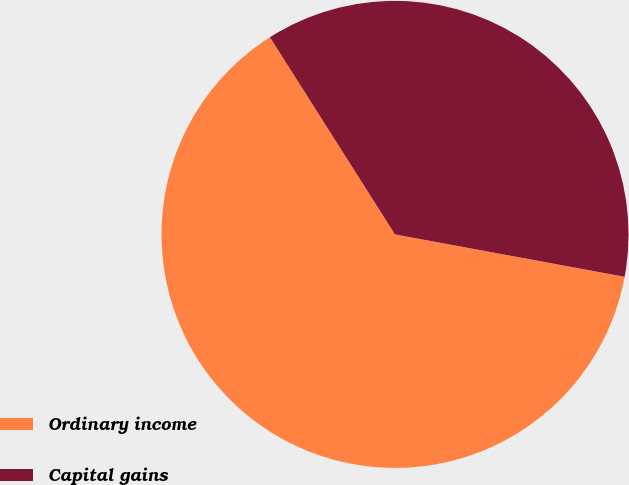Convert chart. <chart><loc_0><loc_0><loc_500><loc_500><pie_chart><fcel>Ordinary income<fcel>Capital gains<nl><fcel>63.1%<fcel>36.9%<nl></chart> 